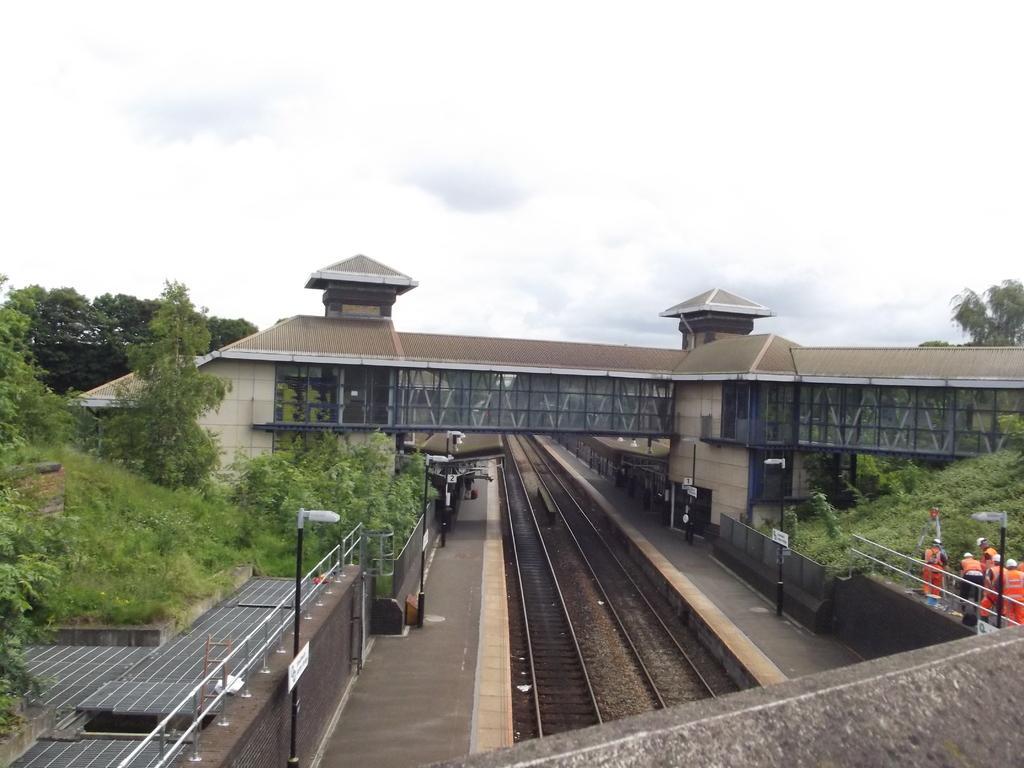Could you give a brief overview of what you see in this image? In this picture we can see railway tracks, platforms, light poles, fences, some people, bridge, trees, some objects and in the background we can see the sky. 